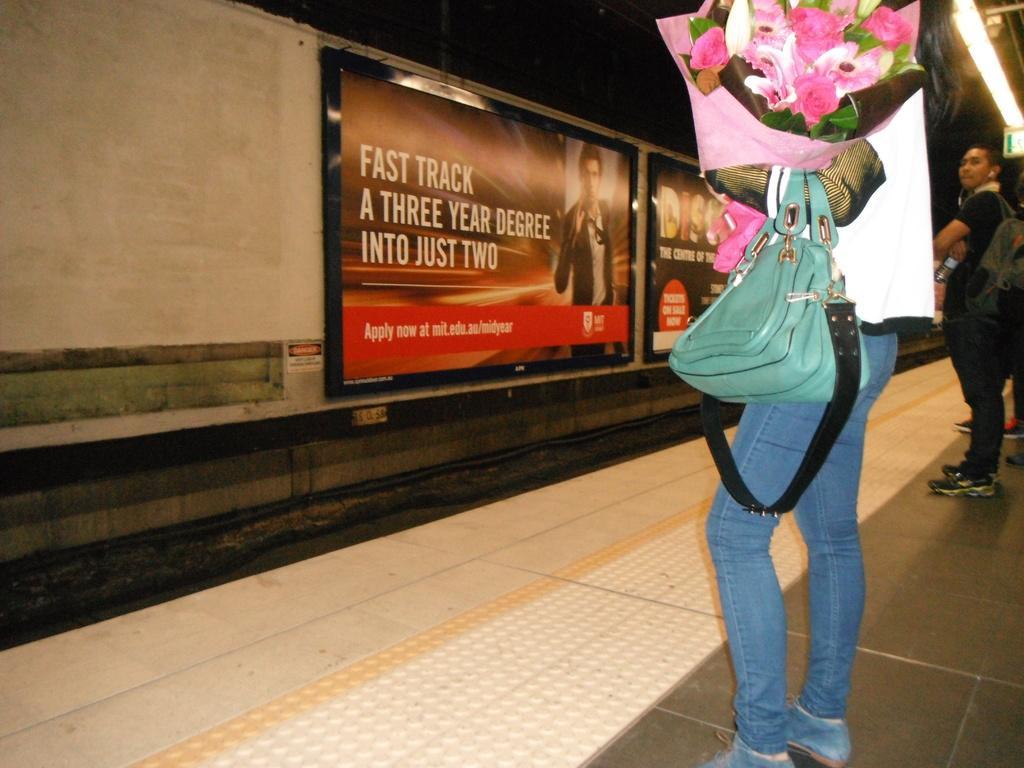How would you summarize this image in a sentence or two? In this image I can see two people are standing. This person is carrying a bag and other objects. Here I can see a wall which has boards attached to it. On the boards I can see person and something written on it. Here I can see a railway track. 